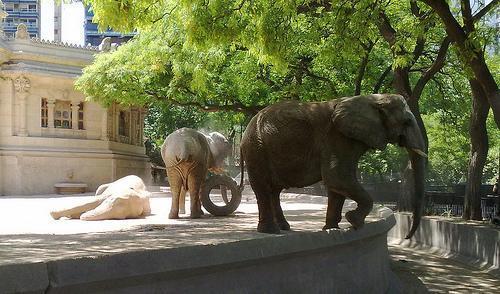How many elephants are there?
Give a very brief answer. 3. How many elephants are lying down?
Give a very brief answer. 1. 